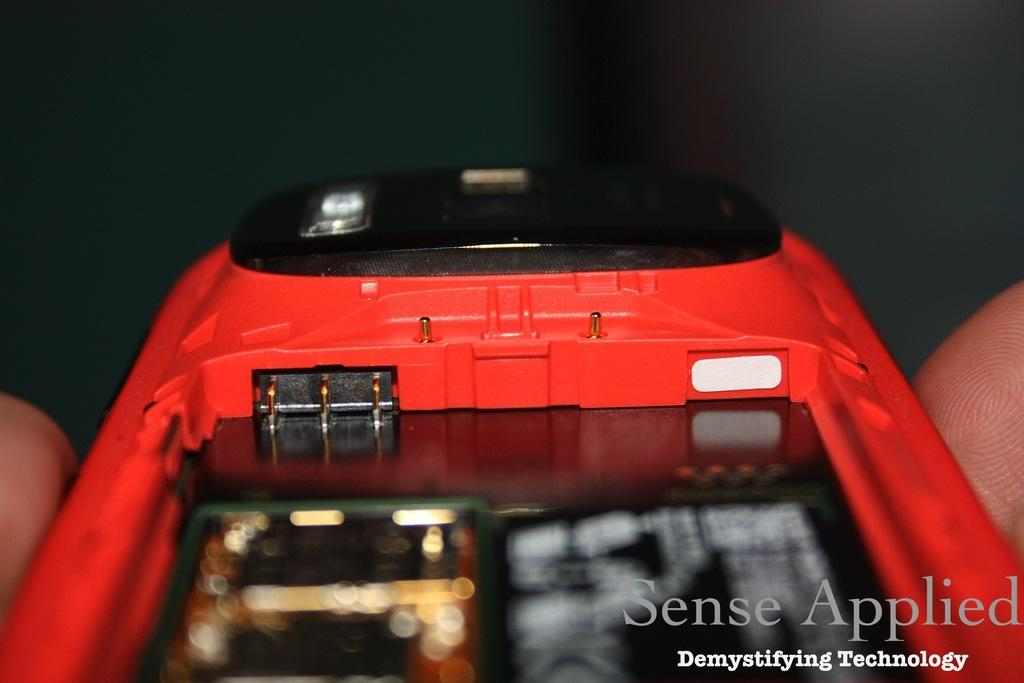<image>
Write a terse but informative summary of the picture. A photo showing the insides of an electronic device with the words Sense Applied in the corner. 